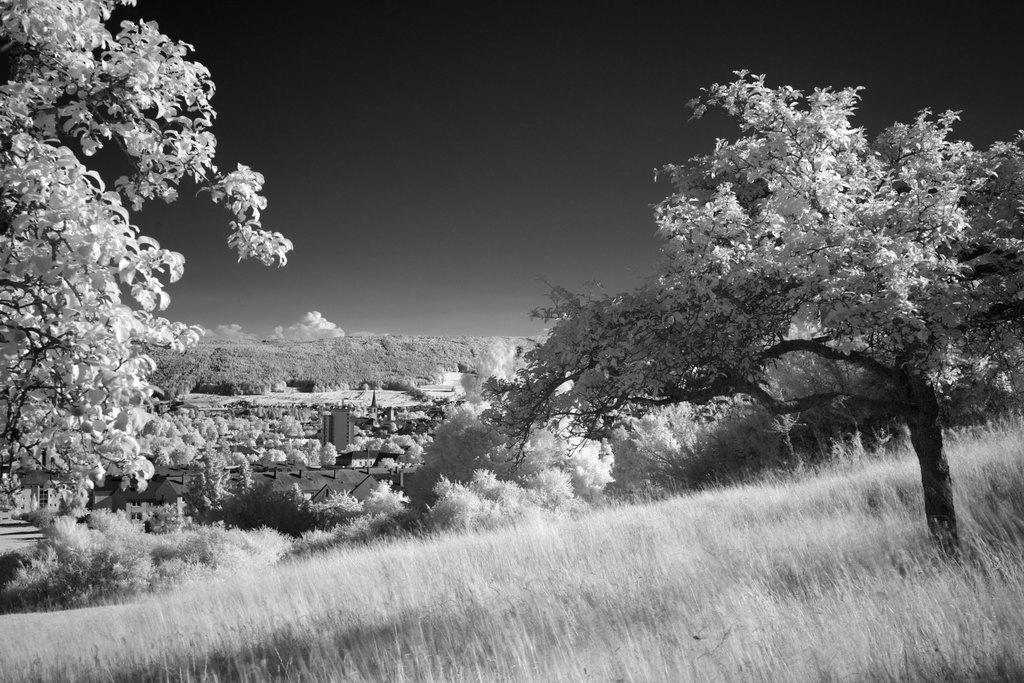Can you describe this image briefly? There is a grass at the bottom of this image. We can see trees in the middle of this image and the sky is in the background. 